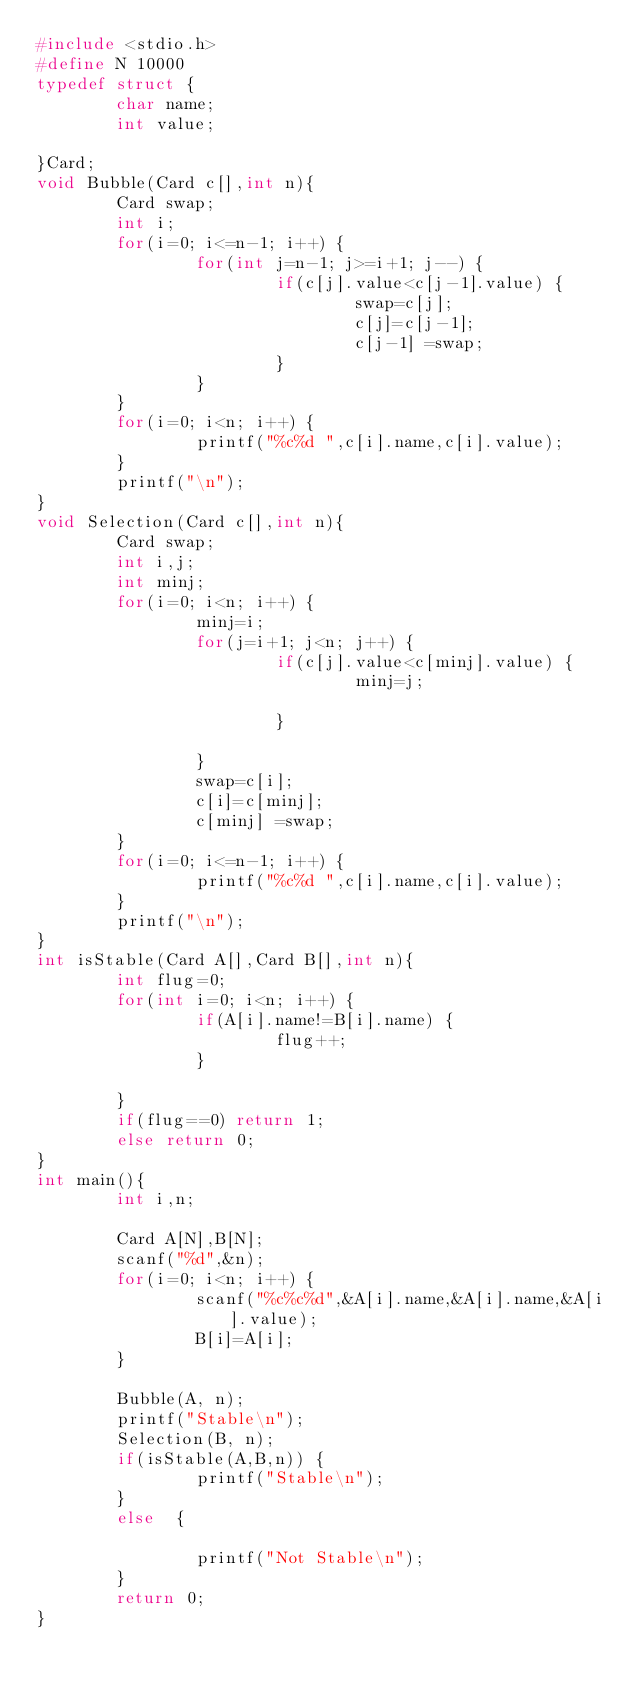<code> <loc_0><loc_0><loc_500><loc_500><_C_>#include <stdio.h>
#define N 10000
typedef struct {
        char name;
        int value;

}Card;
void Bubble(Card c[],int n){
        Card swap;
        int i;
        for(i=0; i<=n-1; i++) {
                for(int j=n-1; j>=i+1; j--) {
                        if(c[j].value<c[j-1].value) {
                                swap=c[j];
                                c[j]=c[j-1];
                                c[j-1] =swap;
                        }
                }
        }
        for(i=0; i<n; i++) {
                printf("%c%d ",c[i].name,c[i].value);
        }
        printf("\n");
}
void Selection(Card c[],int n){
        Card swap;
        int i,j;
        int minj;
        for(i=0; i<n; i++) {
                minj=i;
                for(j=i+1; j<n; j++) {
                        if(c[j].value<c[minj].value) {
                                minj=j;

                        }

                }
                swap=c[i];
                c[i]=c[minj];
                c[minj] =swap;
        }
        for(i=0; i<=n-1; i++) {
                printf("%c%d ",c[i].name,c[i].value);
        }
        printf("\n");
}
int isStable(Card A[],Card B[],int n){
        int flug=0;
        for(int i=0; i<n; i++) {
                if(A[i].name!=B[i].name) {
                        flug++;
                }

        }
        if(flug==0) return 1;
        else return 0;
}
int main(){
        int i,n;

        Card A[N],B[N];
        scanf("%d",&n);
        for(i=0; i<n; i++) {
                scanf("%c%c%d",&A[i].name,&A[i].name,&A[i].value);
                B[i]=A[i];
        }

        Bubble(A, n);
        printf("Stable\n");
        Selection(B, n);
        if(isStable(A,B,n)) {
                printf("Stable\n");
        }
        else  {

                printf("Not Stable\n");
        }
        return 0;
}</code> 